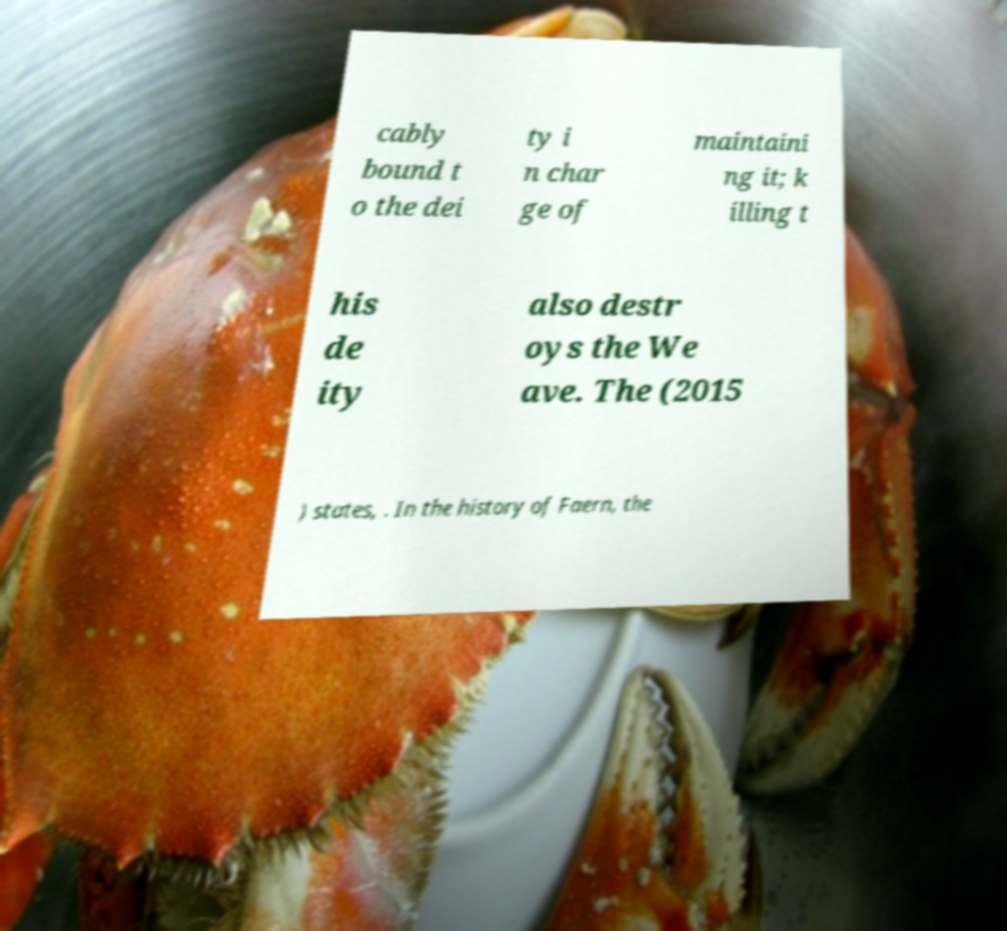I need the written content from this picture converted into text. Can you do that? cably bound t o the dei ty i n char ge of maintaini ng it; k illing t his de ity also destr oys the We ave. The (2015 ) states, . In the history of Faern, the 